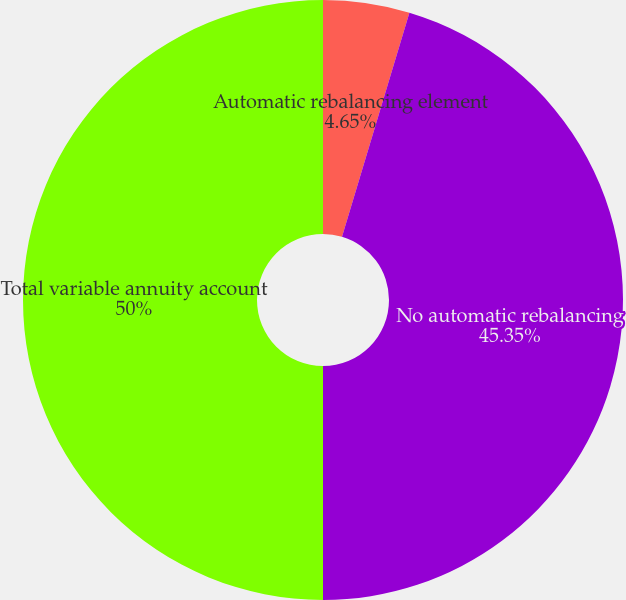Convert chart to OTSL. <chart><loc_0><loc_0><loc_500><loc_500><pie_chart><fcel>Automatic rebalancing element<fcel>No automatic rebalancing<fcel>Total variable annuity account<nl><fcel>4.65%<fcel>45.35%<fcel>50.0%<nl></chart> 